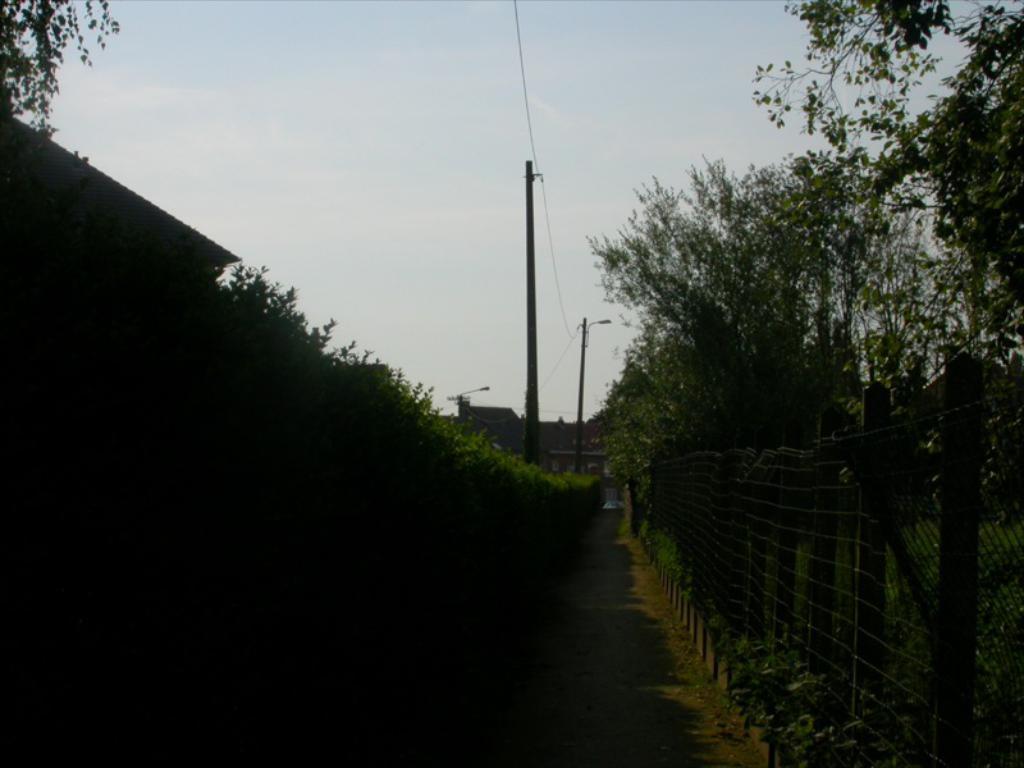How would you summarize this image in a sentence or two? In the middle we can see a path and to either side of path we can see trees and on the right side there is a fence. In the background there are electric poles,wire,buildings and clouds in the sky. 